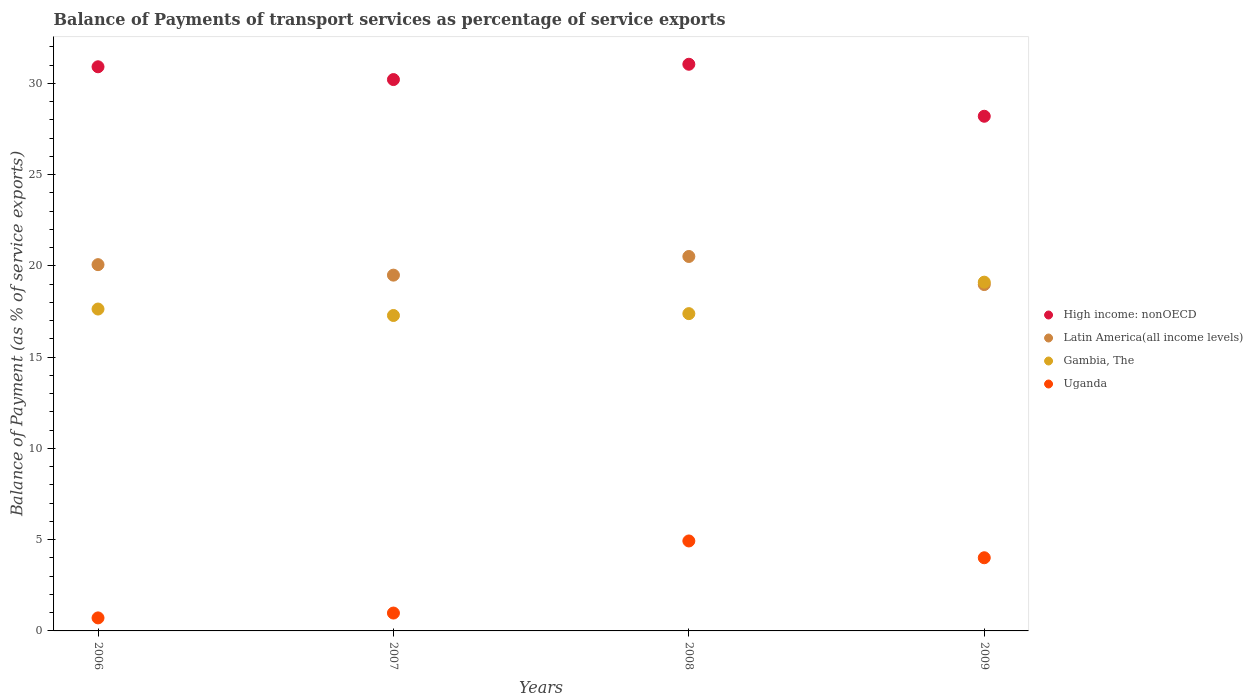Is the number of dotlines equal to the number of legend labels?
Offer a very short reply. Yes. What is the balance of payments of transport services in Uganda in 2007?
Make the answer very short. 0.98. Across all years, what is the maximum balance of payments of transport services in High income: nonOECD?
Provide a succinct answer. 31.05. Across all years, what is the minimum balance of payments of transport services in High income: nonOECD?
Offer a terse response. 28.2. What is the total balance of payments of transport services in Gambia, The in the graph?
Offer a terse response. 71.42. What is the difference between the balance of payments of transport services in High income: nonOECD in 2007 and that in 2009?
Offer a very short reply. 2.01. What is the difference between the balance of payments of transport services in Gambia, The in 2009 and the balance of payments of transport services in Uganda in 2008?
Make the answer very short. 14.18. What is the average balance of payments of transport services in Uganda per year?
Make the answer very short. 2.66. In the year 2009, what is the difference between the balance of payments of transport services in Latin America(all income levels) and balance of payments of transport services in Uganda?
Keep it short and to the point. 14.97. What is the ratio of the balance of payments of transport services in High income: nonOECD in 2006 to that in 2009?
Make the answer very short. 1.1. Is the balance of payments of transport services in High income: nonOECD in 2006 less than that in 2009?
Ensure brevity in your answer.  No. What is the difference between the highest and the second highest balance of payments of transport services in Uganda?
Ensure brevity in your answer.  0.92. What is the difference between the highest and the lowest balance of payments of transport services in Uganda?
Ensure brevity in your answer.  4.22. In how many years, is the balance of payments of transport services in Latin America(all income levels) greater than the average balance of payments of transport services in Latin America(all income levels) taken over all years?
Keep it short and to the point. 2. Is it the case that in every year, the sum of the balance of payments of transport services in Latin America(all income levels) and balance of payments of transport services in Gambia, The  is greater than the balance of payments of transport services in Uganda?
Offer a terse response. Yes. Does the balance of payments of transport services in Uganda monotonically increase over the years?
Offer a very short reply. No. Is the balance of payments of transport services in Latin America(all income levels) strictly greater than the balance of payments of transport services in Gambia, The over the years?
Ensure brevity in your answer.  No. Are the values on the major ticks of Y-axis written in scientific E-notation?
Your answer should be very brief. No. Where does the legend appear in the graph?
Your answer should be compact. Center right. How many legend labels are there?
Provide a succinct answer. 4. How are the legend labels stacked?
Your answer should be very brief. Vertical. What is the title of the graph?
Keep it short and to the point. Balance of Payments of transport services as percentage of service exports. Does "Vietnam" appear as one of the legend labels in the graph?
Provide a short and direct response. No. What is the label or title of the Y-axis?
Keep it short and to the point. Balance of Payment (as % of service exports). What is the Balance of Payment (as % of service exports) of High income: nonOECD in 2006?
Your answer should be compact. 30.91. What is the Balance of Payment (as % of service exports) of Latin America(all income levels) in 2006?
Keep it short and to the point. 20.07. What is the Balance of Payment (as % of service exports) of Gambia, The in 2006?
Give a very brief answer. 17.64. What is the Balance of Payment (as % of service exports) in Uganda in 2006?
Provide a short and direct response. 0.71. What is the Balance of Payment (as % of service exports) in High income: nonOECD in 2007?
Provide a short and direct response. 30.21. What is the Balance of Payment (as % of service exports) in Latin America(all income levels) in 2007?
Keep it short and to the point. 19.5. What is the Balance of Payment (as % of service exports) of Gambia, The in 2007?
Your response must be concise. 17.28. What is the Balance of Payment (as % of service exports) of Uganda in 2007?
Keep it short and to the point. 0.98. What is the Balance of Payment (as % of service exports) in High income: nonOECD in 2008?
Your answer should be compact. 31.05. What is the Balance of Payment (as % of service exports) in Latin America(all income levels) in 2008?
Keep it short and to the point. 20.52. What is the Balance of Payment (as % of service exports) in Gambia, The in 2008?
Ensure brevity in your answer.  17.39. What is the Balance of Payment (as % of service exports) in Uganda in 2008?
Ensure brevity in your answer.  4.93. What is the Balance of Payment (as % of service exports) in High income: nonOECD in 2009?
Offer a very short reply. 28.2. What is the Balance of Payment (as % of service exports) in Latin America(all income levels) in 2009?
Keep it short and to the point. 18.98. What is the Balance of Payment (as % of service exports) of Gambia, The in 2009?
Keep it short and to the point. 19.11. What is the Balance of Payment (as % of service exports) of Uganda in 2009?
Your answer should be very brief. 4.01. Across all years, what is the maximum Balance of Payment (as % of service exports) in High income: nonOECD?
Keep it short and to the point. 31.05. Across all years, what is the maximum Balance of Payment (as % of service exports) in Latin America(all income levels)?
Make the answer very short. 20.52. Across all years, what is the maximum Balance of Payment (as % of service exports) of Gambia, The?
Ensure brevity in your answer.  19.11. Across all years, what is the maximum Balance of Payment (as % of service exports) of Uganda?
Offer a very short reply. 4.93. Across all years, what is the minimum Balance of Payment (as % of service exports) in High income: nonOECD?
Give a very brief answer. 28.2. Across all years, what is the minimum Balance of Payment (as % of service exports) of Latin America(all income levels)?
Provide a succinct answer. 18.98. Across all years, what is the minimum Balance of Payment (as % of service exports) of Gambia, The?
Keep it short and to the point. 17.28. Across all years, what is the minimum Balance of Payment (as % of service exports) in Uganda?
Offer a terse response. 0.71. What is the total Balance of Payment (as % of service exports) in High income: nonOECD in the graph?
Keep it short and to the point. 120.38. What is the total Balance of Payment (as % of service exports) of Latin America(all income levels) in the graph?
Make the answer very short. 79.07. What is the total Balance of Payment (as % of service exports) of Gambia, The in the graph?
Your answer should be compact. 71.42. What is the total Balance of Payment (as % of service exports) of Uganda in the graph?
Make the answer very short. 10.63. What is the difference between the Balance of Payment (as % of service exports) in High income: nonOECD in 2006 and that in 2007?
Your response must be concise. 0.7. What is the difference between the Balance of Payment (as % of service exports) of Latin America(all income levels) in 2006 and that in 2007?
Your answer should be very brief. 0.57. What is the difference between the Balance of Payment (as % of service exports) in Gambia, The in 2006 and that in 2007?
Provide a succinct answer. 0.35. What is the difference between the Balance of Payment (as % of service exports) of Uganda in 2006 and that in 2007?
Your response must be concise. -0.27. What is the difference between the Balance of Payment (as % of service exports) of High income: nonOECD in 2006 and that in 2008?
Offer a very short reply. -0.14. What is the difference between the Balance of Payment (as % of service exports) of Latin America(all income levels) in 2006 and that in 2008?
Ensure brevity in your answer.  -0.45. What is the difference between the Balance of Payment (as % of service exports) in Gambia, The in 2006 and that in 2008?
Your answer should be very brief. 0.25. What is the difference between the Balance of Payment (as % of service exports) of Uganda in 2006 and that in 2008?
Provide a succinct answer. -4.22. What is the difference between the Balance of Payment (as % of service exports) in High income: nonOECD in 2006 and that in 2009?
Give a very brief answer. 2.71. What is the difference between the Balance of Payment (as % of service exports) of Latin America(all income levels) in 2006 and that in 2009?
Your answer should be very brief. 1.09. What is the difference between the Balance of Payment (as % of service exports) in Gambia, The in 2006 and that in 2009?
Keep it short and to the point. -1.47. What is the difference between the Balance of Payment (as % of service exports) in Uganda in 2006 and that in 2009?
Make the answer very short. -3.3. What is the difference between the Balance of Payment (as % of service exports) of High income: nonOECD in 2007 and that in 2008?
Your response must be concise. -0.84. What is the difference between the Balance of Payment (as % of service exports) in Latin America(all income levels) in 2007 and that in 2008?
Ensure brevity in your answer.  -1.02. What is the difference between the Balance of Payment (as % of service exports) of Gambia, The in 2007 and that in 2008?
Your answer should be very brief. -0.1. What is the difference between the Balance of Payment (as % of service exports) in Uganda in 2007 and that in 2008?
Give a very brief answer. -3.95. What is the difference between the Balance of Payment (as % of service exports) in High income: nonOECD in 2007 and that in 2009?
Provide a short and direct response. 2.01. What is the difference between the Balance of Payment (as % of service exports) in Latin America(all income levels) in 2007 and that in 2009?
Give a very brief answer. 0.52. What is the difference between the Balance of Payment (as % of service exports) in Gambia, The in 2007 and that in 2009?
Ensure brevity in your answer.  -1.83. What is the difference between the Balance of Payment (as % of service exports) of Uganda in 2007 and that in 2009?
Make the answer very short. -3.03. What is the difference between the Balance of Payment (as % of service exports) in High income: nonOECD in 2008 and that in 2009?
Offer a very short reply. 2.85. What is the difference between the Balance of Payment (as % of service exports) of Latin America(all income levels) in 2008 and that in 2009?
Offer a very short reply. 1.54. What is the difference between the Balance of Payment (as % of service exports) of Gambia, The in 2008 and that in 2009?
Your answer should be compact. -1.72. What is the difference between the Balance of Payment (as % of service exports) in Uganda in 2008 and that in 2009?
Provide a succinct answer. 0.92. What is the difference between the Balance of Payment (as % of service exports) in High income: nonOECD in 2006 and the Balance of Payment (as % of service exports) in Latin America(all income levels) in 2007?
Offer a very short reply. 11.42. What is the difference between the Balance of Payment (as % of service exports) of High income: nonOECD in 2006 and the Balance of Payment (as % of service exports) of Gambia, The in 2007?
Your response must be concise. 13.63. What is the difference between the Balance of Payment (as % of service exports) of High income: nonOECD in 2006 and the Balance of Payment (as % of service exports) of Uganda in 2007?
Your answer should be compact. 29.93. What is the difference between the Balance of Payment (as % of service exports) in Latin America(all income levels) in 2006 and the Balance of Payment (as % of service exports) in Gambia, The in 2007?
Make the answer very short. 2.79. What is the difference between the Balance of Payment (as % of service exports) of Latin America(all income levels) in 2006 and the Balance of Payment (as % of service exports) of Uganda in 2007?
Make the answer very short. 19.09. What is the difference between the Balance of Payment (as % of service exports) of Gambia, The in 2006 and the Balance of Payment (as % of service exports) of Uganda in 2007?
Make the answer very short. 16.66. What is the difference between the Balance of Payment (as % of service exports) in High income: nonOECD in 2006 and the Balance of Payment (as % of service exports) in Latin America(all income levels) in 2008?
Make the answer very short. 10.39. What is the difference between the Balance of Payment (as % of service exports) of High income: nonOECD in 2006 and the Balance of Payment (as % of service exports) of Gambia, The in 2008?
Give a very brief answer. 13.53. What is the difference between the Balance of Payment (as % of service exports) in High income: nonOECD in 2006 and the Balance of Payment (as % of service exports) in Uganda in 2008?
Offer a very short reply. 25.98. What is the difference between the Balance of Payment (as % of service exports) in Latin America(all income levels) in 2006 and the Balance of Payment (as % of service exports) in Gambia, The in 2008?
Your response must be concise. 2.68. What is the difference between the Balance of Payment (as % of service exports) of Latin America(all income levels) in 2006 and the Balance of Payment (as % of service exports) of Uganda in 2008?
Provide a short and direct response. 15.14. What is the difference between the Balance of Payment (as % of service exports) in Gambia, The in 2006 and the Balance of Payment (as % of service exports) in Uganda in 2008?
Your response must be concise. 12.71. What is the difference between the Balance of Payment (as % of service exports) of High income: nonOECD in 2006 and the Balance of Payment (as % of service exports) of Latin America(all income levels) in 2009?
Make the answer very short. 11.93. What is the difference between the Balance of Payment (as % of service exports) in High income: nonOECD in 2006 and the Balance of Payment (as % of service exports) in Gambia, The in 2009?
Offer a very short reply. 11.8. What is the difference between the Balance of Payment (as % of service exports) in High income: nonOECD in 2006 and the Balance of Payment (as % of service exports) in Uganda in 2009?
Ensure brevity in your answer.  26.9. What is the difference between the Balance of Payment (as % of service exports) of Latin America(all income levels) in 2006 and the Balance of Payment (as % of service exports) of Gambia, The in 2009?
Offer a very short reply. 0.96. What is the difference between the Balance of Payment (as % of service exports) in Latin America(all income levels) in 2006 and the Balance of Payment (as % of service exports) in Uganda in 2009?
Provide a short and direct response. 16.06. What is the difference between the Balance of Payment (as % of service exports) in Gambia, The in 2006 and the Balance of Payment (as % of service exports) in Uganda in 2009?
Your answer should be compact. 13.63. What is the difference between the Balance of Payment (as % of service exports) in High income: nonOECD in 2007 and the Balance of Payment (as % of service exports) in Latin America(all income levels) in 2008?
Give a very brief answer. 9.69. What is the difference between the Balance of Payment (as % of service exports) in High income: nonOECD in 2007 and the Balance of Payment (as % of service exports) in Gambia, The in 2008?
Provide a succinct answer. 12.83. What is the difference between the Balance of Payment (as % of service exports) in High income: nonOECD in 2007 and the Balance of Payment (as % of service exports) in Uganda in 2008?
Your answer should be very brief. 25.28. What is the difference between the Balance of Payment (as % of service exports) in Latin America(all income levels) in 2007 and the Balance of Payment (as % of service exports) in Gambia, The in 2008?
Provide a succinct answer. 2.11. What is the difference between the Balance of Payment (as % of service exports) in Latin America(all income levels) in 2007 and the Balance of Payment (as % of service exports) in Uganda in 2008?
Keep it short and to the point. 14.57. What is the difference between the Balance of Payment (as % of service exports) in Gambia, The in 2007 and the Balance of Payment (as % of service exports) in Uganda in 2008?
Your answer should be very brief. 12.36. What is the difference between the Balance of Payment (as % of service exports) in High income: nonOECD in 2007 and the Balance of Payment (as % of service exports) in Latin America(all income levels) in 2009?
Your response must be concise. 11.23. What is the difference between the Balance of Payment (as % of service exports) of High income: nonOECD in 2007 and the Balance of Payment (as % of service exports) of Gambia, The in 2009?
Keep it short and to the point. 11.1. What is the difference between the Balance of Payment (as % of service exports) of High income: nonOECD in 2007 and the Balance of Payment (as % of service exports) of Uganda in 2009?
Provide a short and direct response. 26.2. What is the difference between the Balance of Payment (as % of service exports) of Latin America(all income levels) in 2007 and the Balance of Payment (as % of service exports) of Gambia, The in 2009?
Your answer should be compact. 0.38. What is the difference between the Balance of Payment (as % of service exports) of Latin America(all income levels) in 2007 and the Balance of Payment (as % of service exports) of Uganda in 2009?
Offer a very short reply. 15.49. What is the difference between the Balance of Payment (as % of service exports) of Gambia, The in 2007 and the Balance of Payment (as % of service exports) of Uganda in 2009?
Ensure brevity in your answer.  13.28. What is the difference between the Balance of Payment (as % of service exports) in High income: nonOECD in 2008 and the Balance of Payment (as % of service exports) in Latin America(all income levels) in 2009?
Your response must be concise. 12.07. What is the difference between the Balance of Payment (as % of service exports) of High income: nonOECD in 2008 and the Balance of Payment (as % of service exports) of Gambia, The in 2009?
Give a very brief answer. 11.94. What is the difference between the Balance of Payment (as % of service exports) in High income: nonOECD in 2008 and the Balance of Payment (as % of service exports) in Uganda in 2009?
Your answer should be compact. 27.04. What is the difference between the Balance of Payment (as % of service exports) of Latin America(all income levels) in 2008 and the Balance of Payment (as % of service exports) of Gambia, The in 2009?
Provide a succinct answer. 1.41. What is the difference between the Balance of Payment (as % of service exports) in Latin America(all income levels) in 2008 and the Balance of Payment (as % of service exports) in Uganda in 2009?
Give a very brief answer. 16.51. What is the difference between the Balance of Payment (as % of service exports) of Gambia, The in 2008 and the Balance of Payment (as % of service exports) of Uganda in 2009?
Make the answer very short. 13.38. What is the average Balance of Payment (as % of service exports) in High income: nonOECD per year?
Your answer should be compact. 30.1. What is the average Balance of Payment (as % of service exports) of Latin America(all income levels) per year?
Your answer should be very brief. 19.77. What is the average Balance of Payment (as % of service exports) in Gambia, The per year?
Ensure brevity in your answer.  17.86. What is the average Balance of Payment (as % of service exports) of Uganda per year?
Your response must be concise. 2.66. In the year 2006, what is the difference between the Balance of Payment (as % of service exports) of High income: nonOECD and Balance of Payment (as % of service exports) of Latin America(all income levels)?
Your response must be concise. 10.84. In the year 2006, what is the difference between the Balance of Payment (as % of service exports) in High income: nonOECD and Balance of Payment (as % of service exports) in Gambia, The?
Your answer should be very brief. 13.28. In the year 2006, what is the difference between the Balance of Payment (as % of service exports) in High income: nonOECD and Balance of Payment (as % of service exports) in Uganda?
Your answer should be compact. 30.2. In the year 2006, what is the difference between the Balance of Payment (as % of service exports) of Latin America(all income levels) and Balance of Payment (as % of service exports) of Gambia, The?
Provide a short and direct response. 2.43. In the year 2006, what is the difference between the Balance of Payment (as % of service exports) of Latin America(all income levels) and Balance of Payment (as % of service exports) of Uganda?
Your answer should be very brief. 19.36. In the year 2006, what is the difference between the Balance of Payment (as % of service exports) in Gambia, The and Balance of Payment (as % of service exports) in Uganda?
Offer a terse response. 16.93. In the year 2007, what is the difference between the Balance of Payment (as % of service exports) of High income: nonOECD and Balance of Payment (as % of service exports) of Latin America(all income levels)?
Your answer should be very brief. 10.72. In the year 2007, what is the difference between the Balance of Payment (as % of service exports) in High income: nonOECD and Balance of Payment (as % of service exports) in Gambia, The?
Your response must be concise. 12.93. In the year 2007, what is the difference between the Balance of Payment (as % of service exports) of High income: nonOECD and Balance of Payment (as % of service exports) of Uganda?
Offer a very short reply. 29.23. In the year 2007, what is the difference between the Balance of Payment (as % of service exports) of Latin America(all income levels) and Balance of Payment (as % of service exports) of Gambia, The?
Keep it short and to the point. 2.21. In the year 2007, what is the difference between the Balance of Payment (as % of service exports) in Latin America(all income levels) and Balance of Payment (as % of service exports) in Uganda?
Your answer should be very brief. 18.52. In the year 2007, what is the difference between the Balance of Payment (as % of service exports) of Gambia, The and Balance of Payment (as % of service exports) of Uganda?
Ensure brevity in your answer.  16.31. In the year 2008, what is the difference between the Balance of Payment (as % of service exports) of High income: nonOECD and Balance of Payment (as % of service exports) of Latin America(all income levels)?
Make the answer very short. 10.53. In the year 2008, what is the difference between the Balance of Payment (as % of service exports) of High income: nonOECD and Balance of Payment (as % of service exports) of Gambia, The?
Your answer should be very brief. 13.67. In the year 2008, what is the difference between the Balance of Payment (as % of service exports) in High income: nonOECD and Balance of Payment (as % of service exports) in Uganda?
Offer a terse response. 26.12. In the year 2008, what is the difference between the Balance of Payment (as % of service exports) of Latin America(all income levels) and Balance of Payment (as % of service exports) of Gambia, The?
Give a very brief answer. 3.13. In the year 2008, what is the difference between the Balance of Payment (as % of service exports) in Latin America(all income levels) and Balance of Payment (as % of service exports) in Uganda?
Your answer should be compact. 15.59. In the year 2008, what is the difference between the Balance of Payment (as % of service exports) of Gambia, The and Balance of Payment (as % of service exports) of Uganda?
Provide a short and direct response. 12.46. In the year 2009, what is the difference between the Balance of Payment (as % of service exports) in High income: nonOECD and Balance of Payment (as % of service exports) in Latin America(all income levels)?
Keep it short and to the point. 9.22. In the year 2009, what is the difference between the Balance of Payment (as % of service exports) in High income: nonOECD and Balance of Payment (as % of service exports) in Gambia, The?
Your response must be concise. 9.09. In the year 2009, what is the difference between the Balance of Payment (as % of service exports) of High income: nonOECD and Balance of Payment (as % of service exports) of Uganda?
Keep it short and to the point. 24.19. In the year 2009, what is the difference between the Balance of Payment (as % of service exports) of Latin America(all income levels) and Balance of Payment (as % of service exports) of Gambia, The?
Your response must be concise. -0.13. In the year 2009, what is the difference between the Balance of Payment (as % of service exports) in Latin America(all income levels) and Balance of Payment (as % of service exports) in Uganda?
Ensure brevity in your answer.  14.97. In the year 2009, what is the difference between the Balance of Payment (as % of service exports) of Gambia, The and Balance of Payment (as % of service exports) of Uganda?
Give a very brief answer. 15.1. What is the ratio of the Balance of Payment (as % of service exports) of High income: nonOECD in 2006 to that in 2007?
Provide a succinct answer. 1.02. What is the ratio of the Balance of Payment (as % of service exports) of Latin America(all income levels) in 2006 to that in 2007?
Ensure brevity in your answer.  1.03. What is the ratio of the Balance of Payment (as % of service exports) in Gambia, The in 2006 to that in 2007?
Make the answer very short. 1.02. What is the ratio of the Balance of Payment (as % of service exports) of Uganda in 2006 to that in 2007?
Ensure brevity in your answer.  0.73. What is the ratio of the Balance of Payment (as % of service exports) of Latin America(all income levels) in 2006 to that in 2008?
Your answer should be compact. 0.98. What is the ratio of the Balance of Payment (as % of service exports) of Gambia, The in 2006 to that in 2008?
Ensure brevity in your answer.  1.01. What is the ratio of the Balance of Payment (as % of service exports) in Uganda in 2006 to that in 2008?
Make the answer very short. 0.14. What is the ratio of the Balance of Payment (as % of service exports) of High income: nonOECD in 2006 to that in 2009?
Keep it short and to the point. 1.1. What is the ratio of the Balance of Payment (as % of service exports) in Latin America(all income levels) in 2006 to that in 2009?
Make the answer very short. 1.06. What is the ratio of the Balance of Payment (as % of service exports) of Gambia, The in 2006 to that in 2009?
Keep it short and to the point. 0.92. What is the ratio of the Balance of Payment (as % of service exports) of Uganda in 2006 to that in 2009?
Ensure brevity in your answer.  0.18. What is the ratio of the Balance of Payment (as % of service exports) of Latin America(all income levels) in 2007 to that in 2008?
Ensure brevity in your answer.  0.95. What is the ratio of the Balance of Payment (as % of service exports) of Uganda in 2007 to that in 2008?
Your answer should be compact. 0.2. What is the ratio of the Balance of Payment (as % of service exports) in High income: nonOECD in 2007 to that in 2009?
Your response must be concise. 1.07. What is the ratio of the Balance of Payment (as % of service exports) of Latin America(all income levels) in 2007 to that in 2009?
Offer a very short reply. 1.03. What is the ratio of the Balance of Payment (as % of service exports) in Gambia, The in 2007 to that in 2009?
Your answer should be compact. 0.9. What is the ratio of the Balance of Payment (as % of service exports) in Uganda in 2007 to that in 2009?
Ensure brevity in your answer.  0.24. What is the ratio of the Balance of Payment (as % of service exports) of High income: nonOECD in 2008 to that in 2009?
Offer a very short reply. 1.1. What is the ratio of the Balance of Payment (as % of service exports) of Latin America(all income levels) in 2008 to that in 2009?
Your response must be concise. 1.08. What is the ratio of the Balance of Payment (as % of service exports) of Gambia, The in 2008 to that in 2009?
Your response must be concise. 0.91. What is the ratio of the Balance of Payment (as % of service exports) in Uganda in 2008 to that in 2009?
Provide a succinct answer. 1.23. What is the difference between the highest and the second highest Balance of Payment (as % of service exports) of High income: nonOECD?
Provide a short and direct response. 0.14. What is the difference between the highest and the second highest Balance of Payment (as % of service exports) of Latin America(all income levels)?
Your answer should be very brief. 0.45. What is the difference between the highest and the second highest Balance of Payment (as % of service exports) of Gambia, The?
Provide a succinct answer. 1.47. What is the difference between the highest and the second highest Balance of Payment (as % of service exports) of Uganda?
Keep it short and to the point. 0.92. What is the difference between the highest and the lowest Balance of Payment (as % of service exports) of High income: nonOECD?
Make the answer very short. 2.85. What is the difference between the highest and the lowest Balance of Payment (as % of service exports) in Latin America(all income levels)?
Provide a short and direct response. 1.54. What is the difference between the highest and the lowest Balance of Payment (as % of service exports) of Gambia, The?
Give a very brief answer. 1.83. What is the difference between the highest and the lowest Balance of Payment (as % of service exports) of Uganda?
Your answer should be very brief. 4.22. 